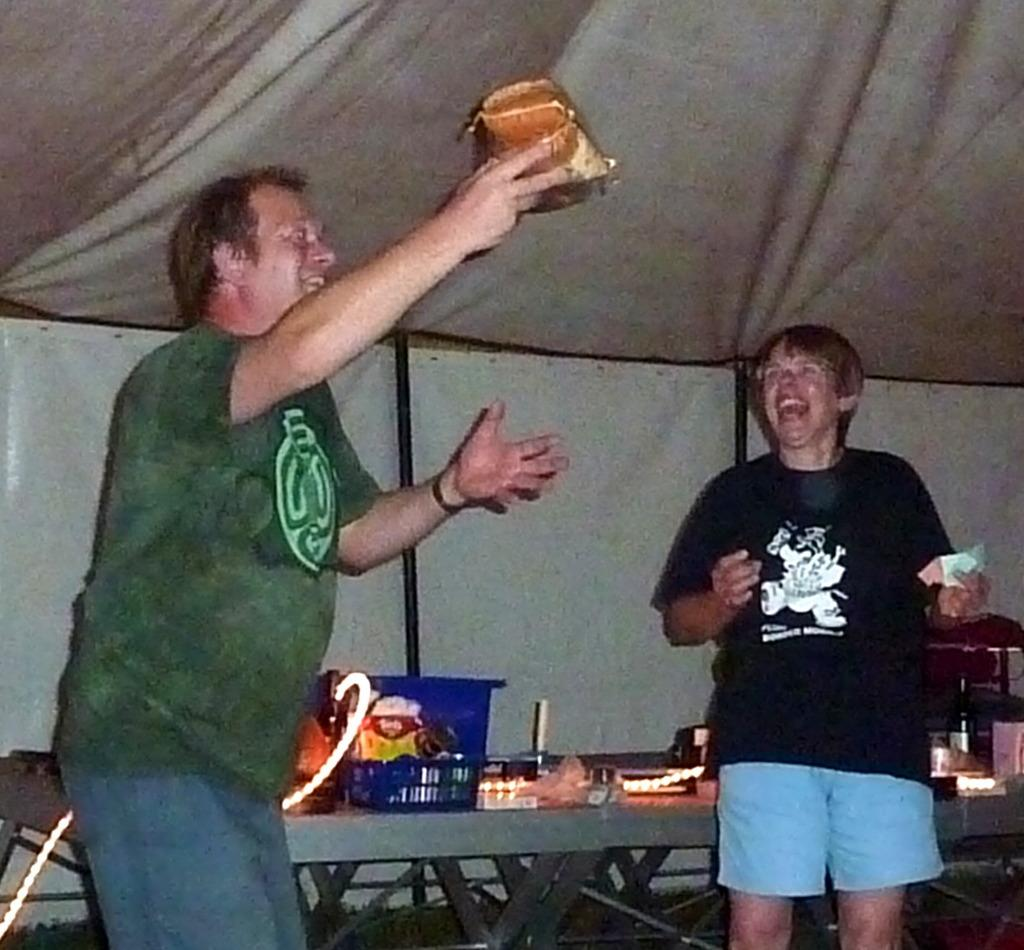How many people are in the image? There are two men standing in the image. What is the facial expression of the men? The men are smiling. What is one of the men holding in the image? One of the men is holding an object, possibly a tent. What is present on the table in the image? There is a table in the image with a basket, lights, and other unspecified objects on it. What type of surprise is hidden in the basket on the table? There is no indication of a surprise in the basket or any other part of the image. 